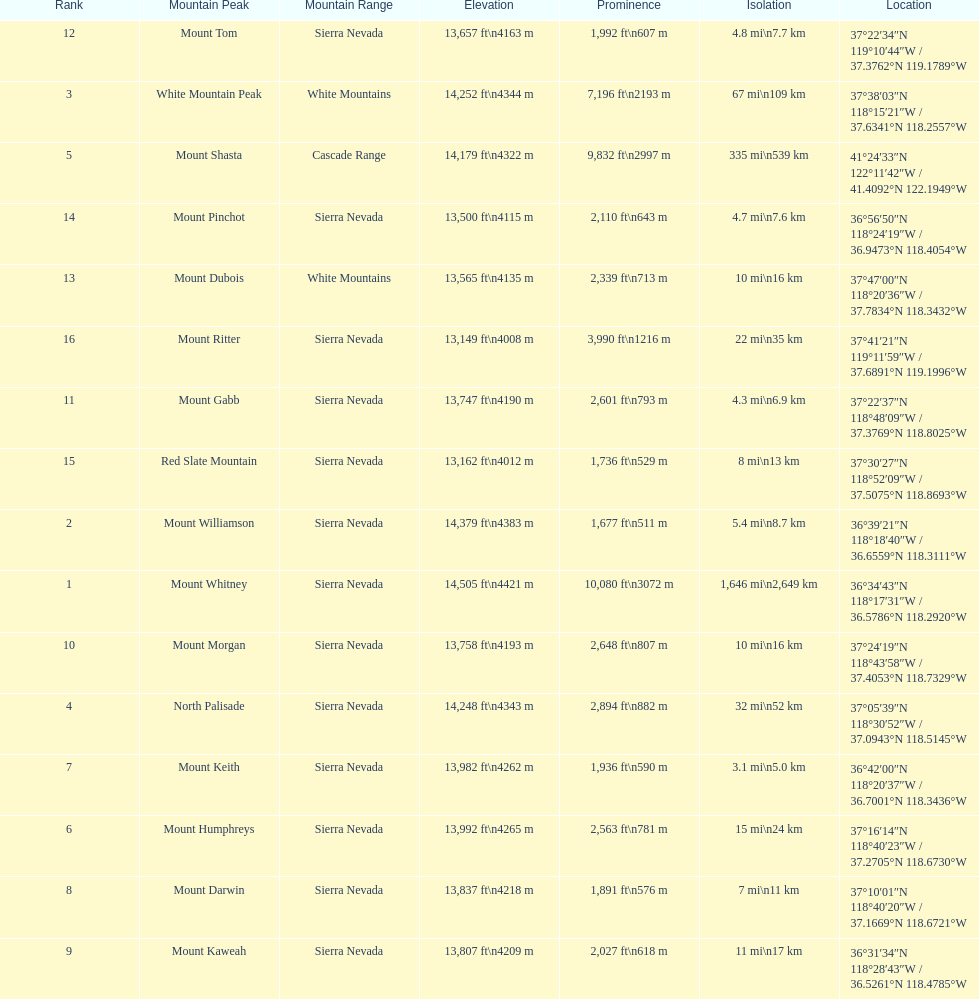What is the only mountain peak listed for the cascade range? Mount Shasta. 